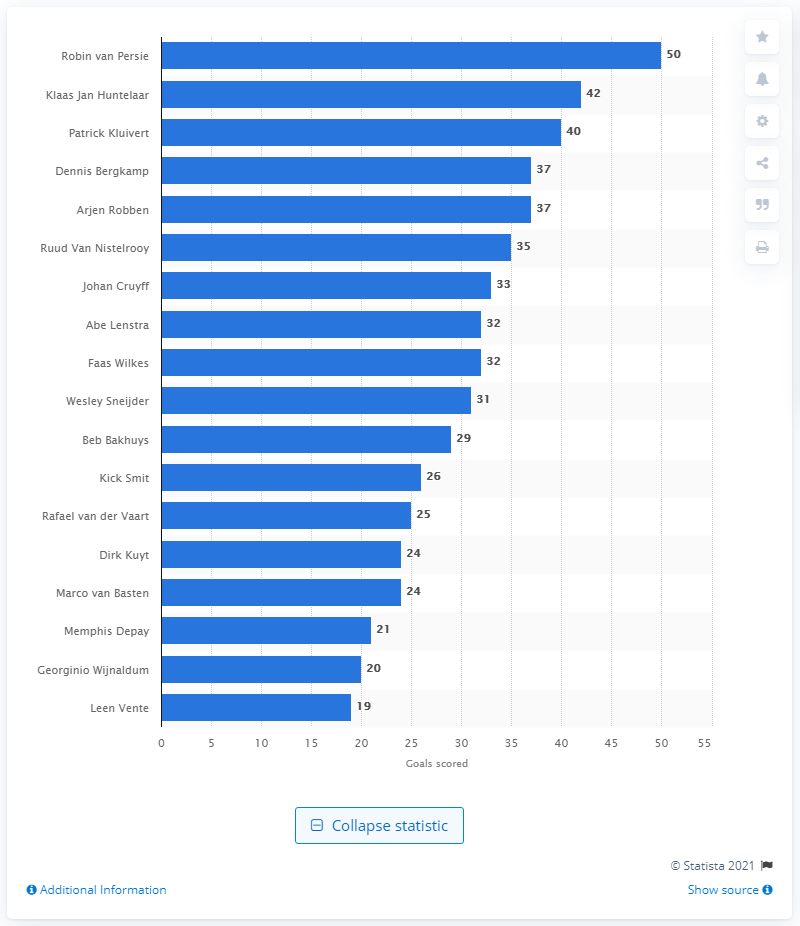Mention a couple of crucial points in this snapshot. Robin Van Persie has scored 50 goals for the Dutch national football team. I, Patrick Kluivert, have scored a total of 40 goals. 